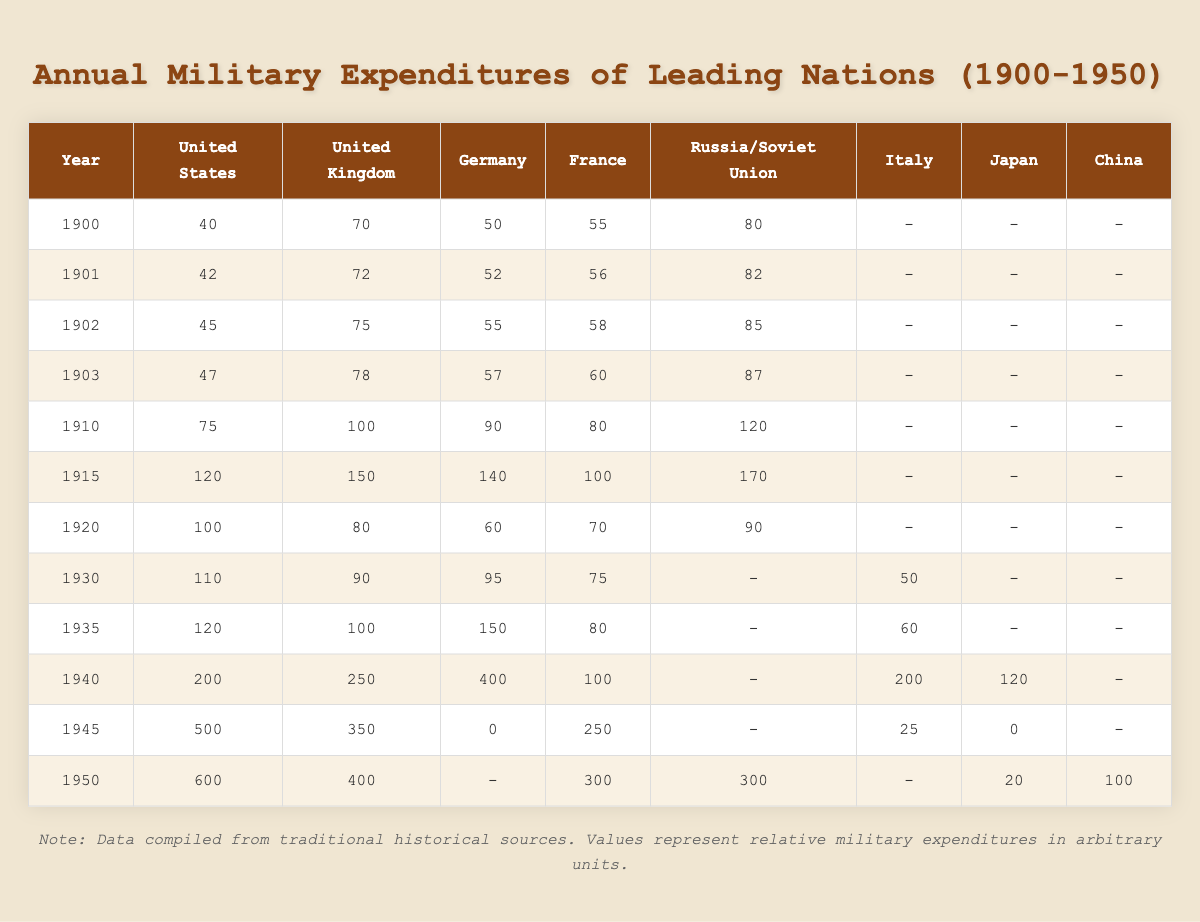What was the military expenditure of the United States in 1905? The table does not provide data for the year 1905, so we cannot ascertain the military expenditure for that specific year.
Answer: No data available for 1905 Which country had the highest military expenditure in 1940? In 1940, Germany had the highest military expenditure at 400 units.
Answer: Germany What was the increase in military expenditure for the United States between 1940 and 1950? The expenditure for the United States in 1940 was 200 units and in 1950 it was 600 units. The increase is calculated as 600 - 200 = 400 units.
Answer: 400 units Did Japan have military expenditures recorded for both 1945 and 1950? Yes, Japan had expenditures recorded as 0 in 1945 and 20 in 1950.
Answer: Yes What is the average military expenditure of the United Kingdom from 1900 to 1950? The United Kingdom’s expenditures are 70, 72, 75, 78, 100, 150, 80, 90, 100, 250, 350, and 400, forming a total of 10 data points. The sum is 70 + 72 + 75 + 78 + 100 + 150 + 80 + 90 + 100 + 250 + 350 + 400 = 2565. Therefore, the average is 2565 / 12 = 213.75.
Answer: 213.75 Which year saw a significant drop in Germany's military expenditure, and what was that amount? The significant drop occurred in 1945 when Germany’s military expenditure was recorded as 0 units, compared to previous years where it had higher expenditures.
Answer: 0 units in 1945 If we compare the military spending of Italy in 1940 and 1950, what is the difference? Italy's expenditure in 1940 was 200 units, and in 1950, it was 0 units. The difference is calculated as 200 - 0 = 200 units.
Answer: 200 units What was the ratio of military expenditure between the United States and France in 1915? In 1915, the United States spent 120 units while France spent 100 units. The ratio of U.S. expenditure to France's expenditure is 120:100, which simplifies to 6:5.
Answer: 6:5 Which country consistently had the highest military expenditure from 1940 to 1950? The United States consistently had the highest military expenditure, with 200 units in 1940 increasing to 600 units by 1950.
Answer: United States What was the total military expenditure for all countries listed in 1935? In 1935, the expenditures were United States 120, United Kingdom 100, Germany 150, France 80, and Italy 60. The total is calculated as 120 + 100 + 150 + 80 + 60 = 510.
Answer: 510 units Was Russia's military expenditure in 1910 higher or lower than that of the United Kingdom? In 1910, Russia spent 120 units, while the United Kingdom spent 100 units, indicating that Russia's expenditure was higher.
Answer: Higher 